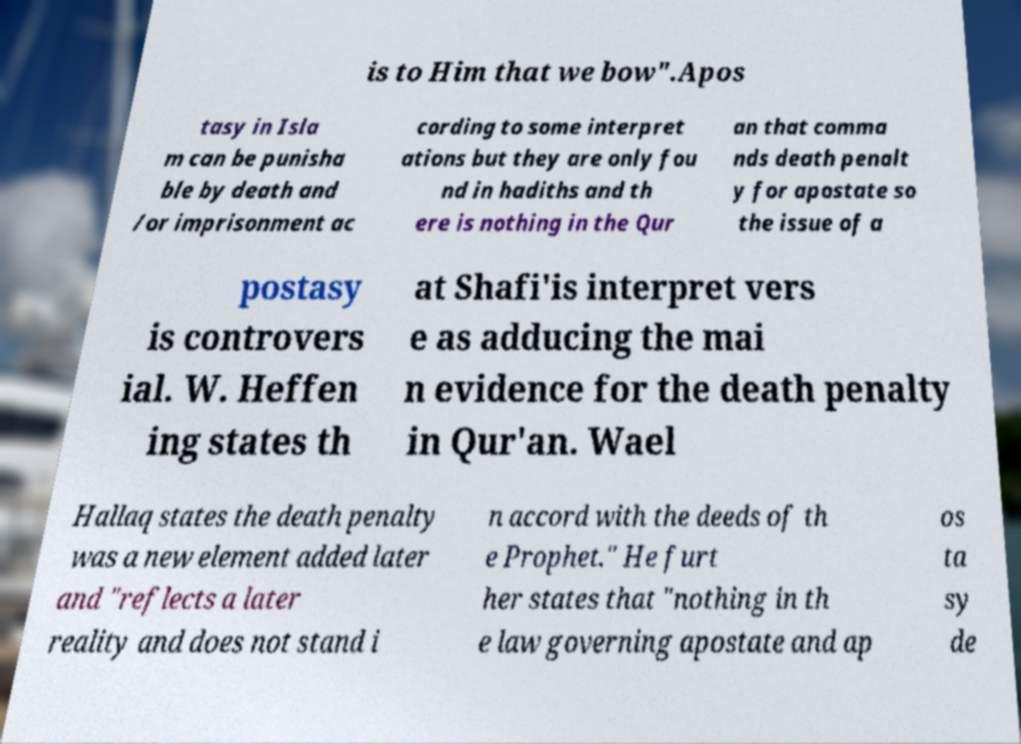For documentation purposes, I need the text within this image transcribed. Could you provide that? is to Him that we bow".Apos tasy in Isla m can be punisha ble by death and /or imprisonment ac cording to some interpret ations but they are only fou nd in hadiths and th ere is nothing in the Qur an that comma nds death penalt y for apostate so the issue of a postasy is controvers ial. W. Heffen ing states th at Shafi'is interpret vers e as adducing the mai n evidence for the death penalty in Qur'an. Wael Hallaq states the death penalty was a new element added later and "reflects a later reality and does not stand i n accord with the deeds of th e Prophet." He furt her states that "nothing in th e law governing apostate and ap os ta sy de 